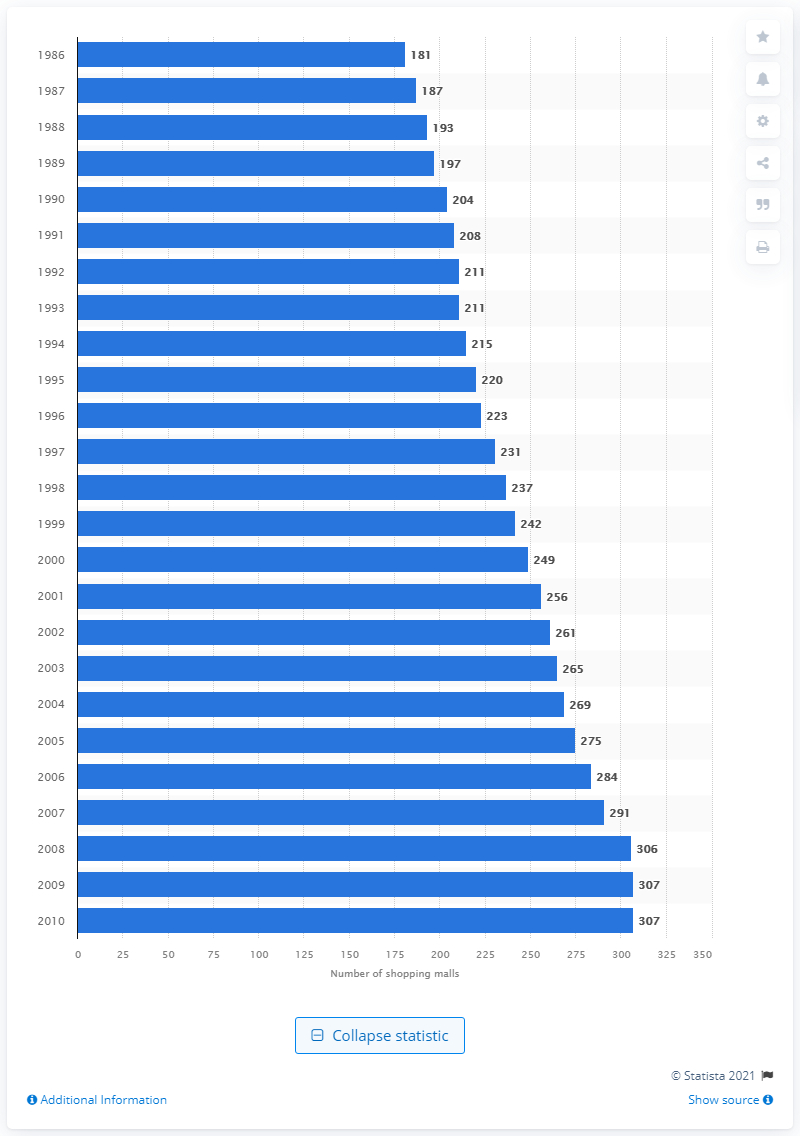Draw attention to some important aspects in this diagram. There were 181 shopping malls in the United States in 1986. 